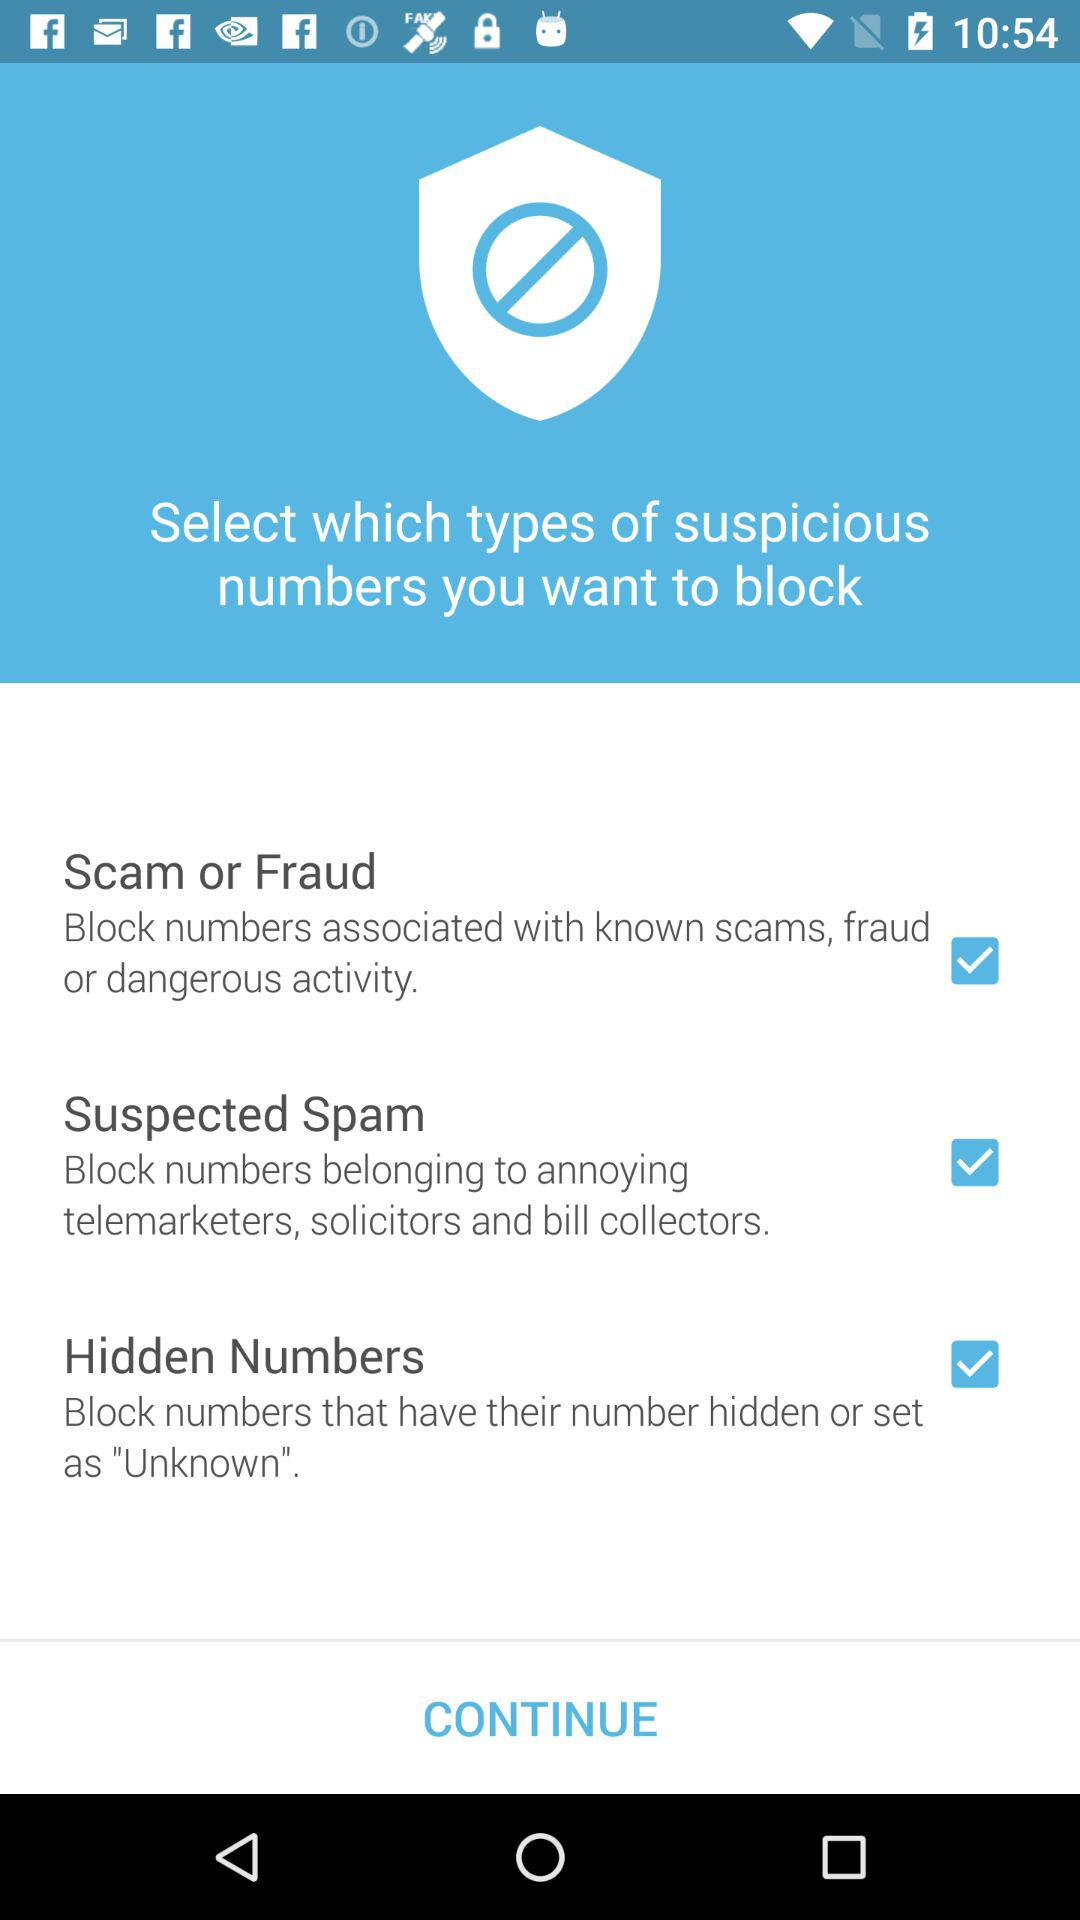What is the status of the "Scam or Fraud"? The status is "on". 